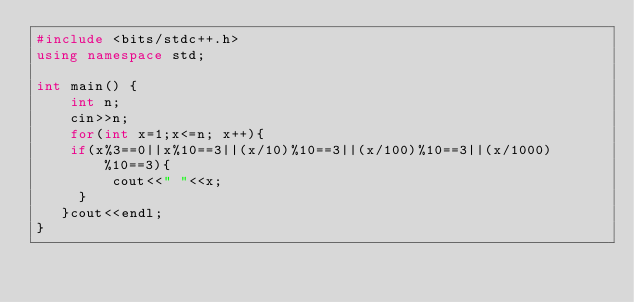Convert code to text. <code><loc_0><loc_0><loc_500><loc_500><_C++_>#include <bits/stdc++.h>
using namespace std;

int main() {
    int n;
    cin>>n;
    for(int x=1;x<=n; x++){
		if(x%3==0||x%10==3||(x/10)%10==3||(x/100)%10==3||(x/1000)%10==3){
	       cout<<" "<<x;
	   }
   }cout<<endl;
}
			
     

         
            

</code> 